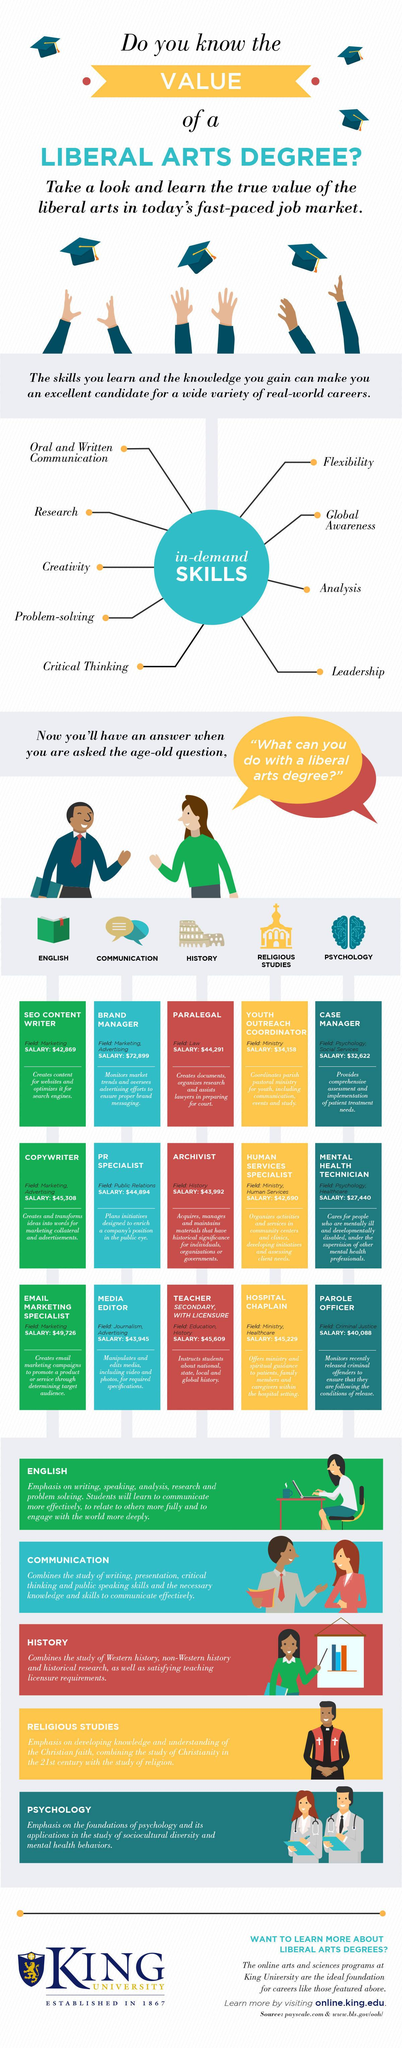Indicate a few pertinent items in this graphic. The archivist belongs to the field of history. The total number of in-demand skills is 9. A copywriter is a professional who belongs to the field of marketing and advertising and is responsible for creating written content for various purposes, such as promoting a product or service. The profession of a parole officer falls under the field of Criminal Justice. 